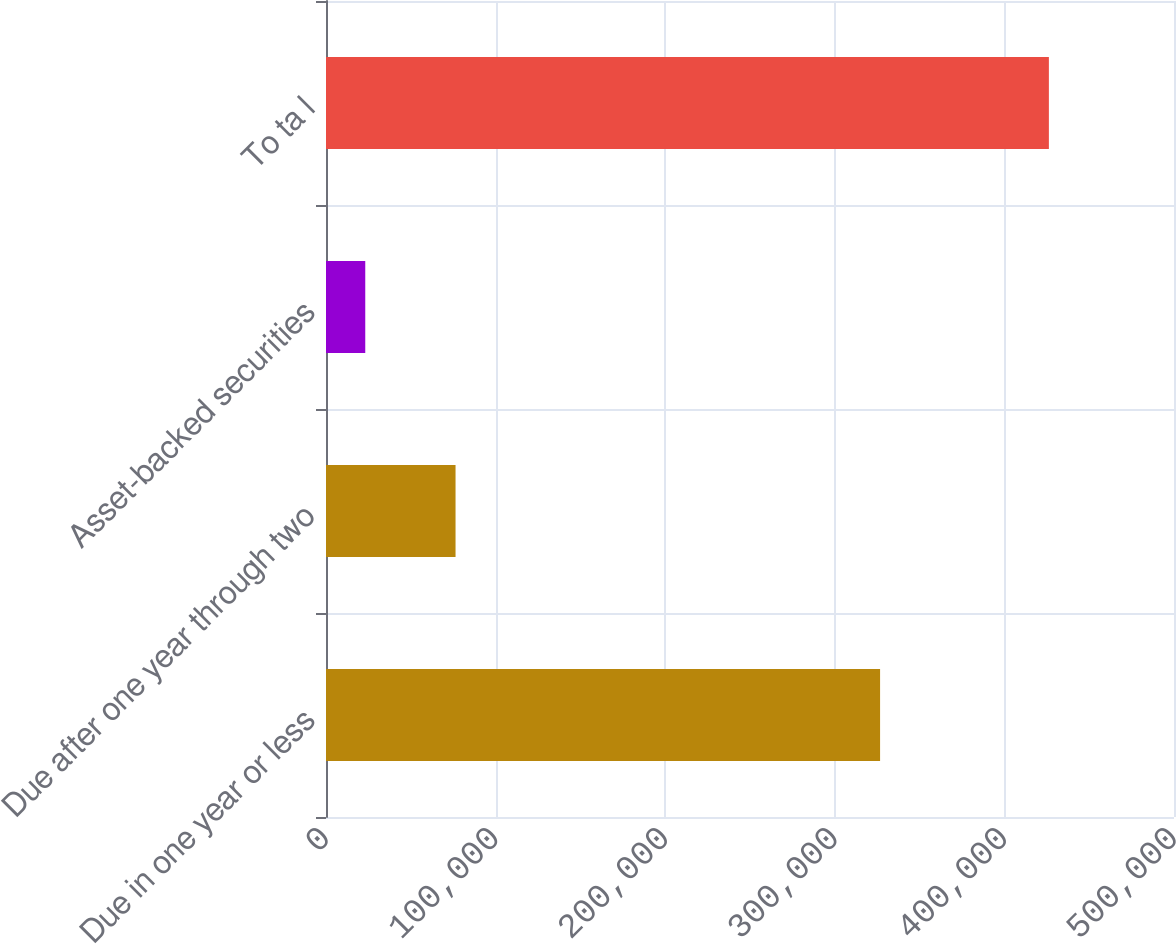Convert chart to OTSL. <chart><loc_0><loc_0><loc_500><loc_500><bar_chart><fcel>Due in one year or less<fcel>Due after one year through two<fcel>Asset-backed securities<fcel>To ta l<nl><fcel>326699<fcel>76381<fcel>23149<fcel>426229<nl></chart> 